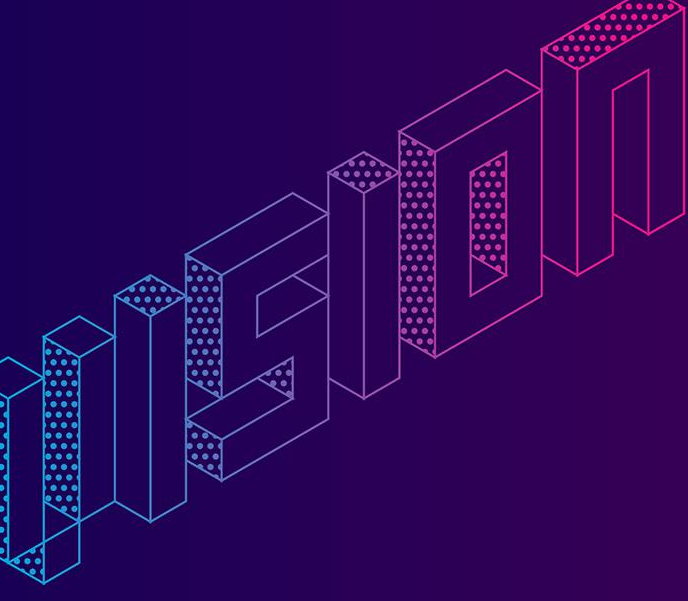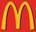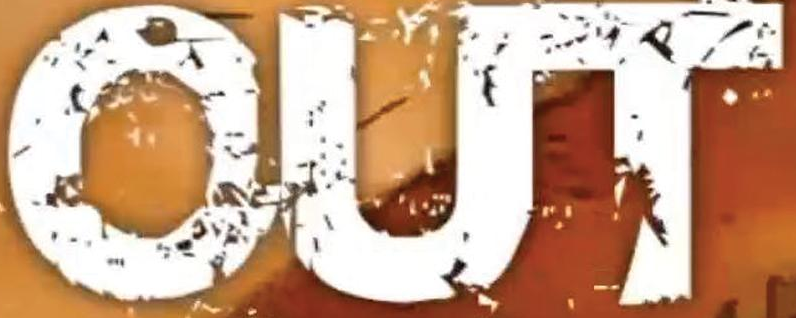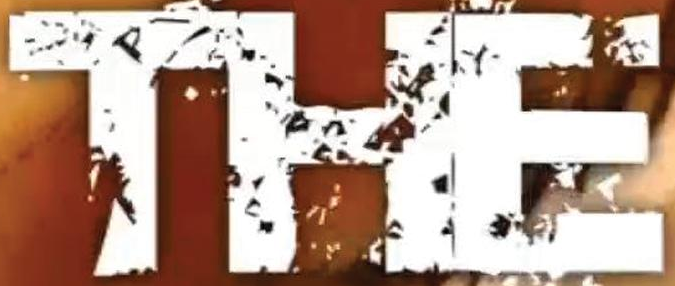Read the text from these images in sequence, separated by a semicolon. VISION; m; OUT; THE 